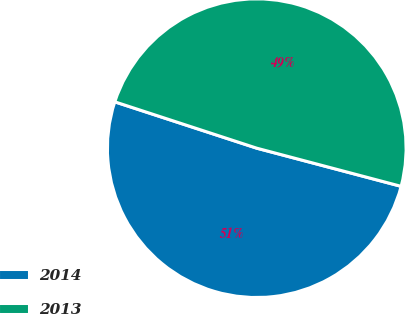<chart> <loc_0><loc_0><loc_500><loc_500><pie_chart><fcel>2014<fcel>2013<nl><fcel>50.91%<fcel>49.09%<nl></chart> 